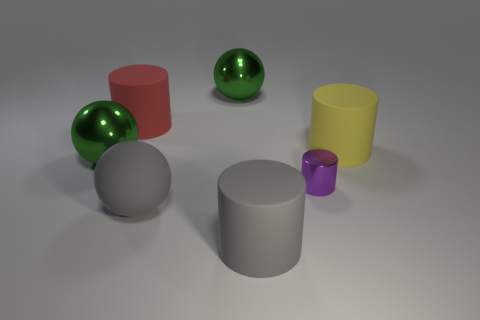What shape is the big thing that is in front of the purple metallic cylinder and behind the gray matte cylinder?
Provide a succinct answer. Sphere. Is the number of big green things greater than the number of cylinders?
Your answer should be compact. No. What is the material of the large red object?
Keep it short and to the point. Rubber. Is there any other thing that has the same size as the purple object?
Offer a very short reply. No. There is a purple metal object that is the same shape as the large yellow object; what is its size?
Offer a terse response. Small. Is there a big object that is to the right of the large green thing on the right side of the large gray sphere?
Ensure brevity in your answer.  Yes. What number of other things are there of the same shape as the purple metallic object?
Your answer should be very brief. 3. Are there more tiny purple cylinders that are left of the yellow object than large gray rubber objects left of the large red thing?
Your answer should be very brief. Yes. Does the cylinder that is in front of the small metal object have the same size as the shiny ball behind the big red object?
Provide a succinct answer. Yes. There is a red object; what shape is it?
Offer a very short reply. Cylinder. 